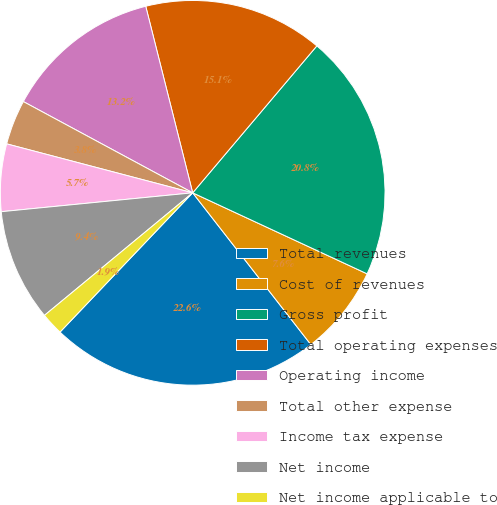Convert chart. <chart><loc_0><loc_0><loc_500><loc_500><pie_chart><fcel>Total revenues<fcel>Cost of revenues<fcel>Gross profit<fcel>Total operating expenses<fcel>Operating income<fcel>Total other expense<fcel>Income tax expense<fcel>Net income<fcel>Net income applicable to<nl><fcel>22.64%<fcel>7.55%<fcel>20.75%<fcel>15.09%<fcel>13.21%<fcel>3.77%<fcel>5.66%<fcel>9.43%<fcel>1.89%<nl></chart> 